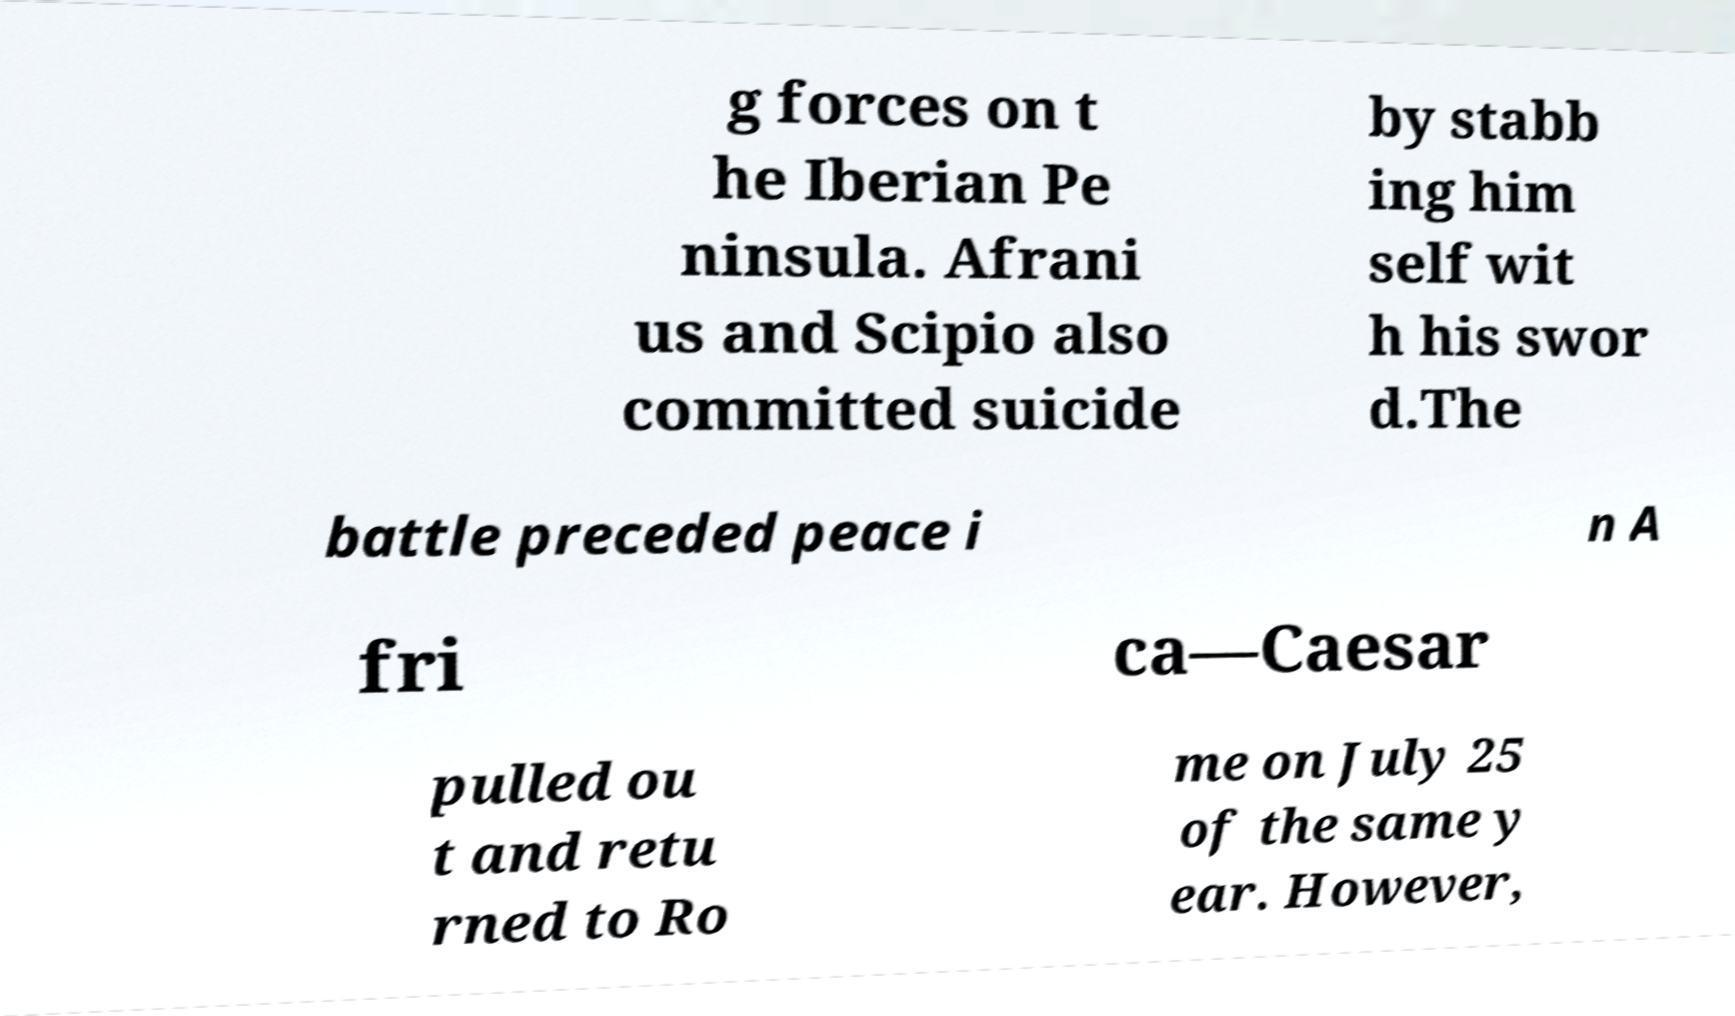There's text embedded in this image that I need extracted. Can you transcribe it verbatim? g forces on t he Iberian Pe ninsula. Afrani us and Scipio also committed suicide by stabb ing him self wit h his swor d.The battle preceded peace i n A fri ca—Caesar pulled ou t and retu rned to Ro me on July 25 of the same y ear. However, 